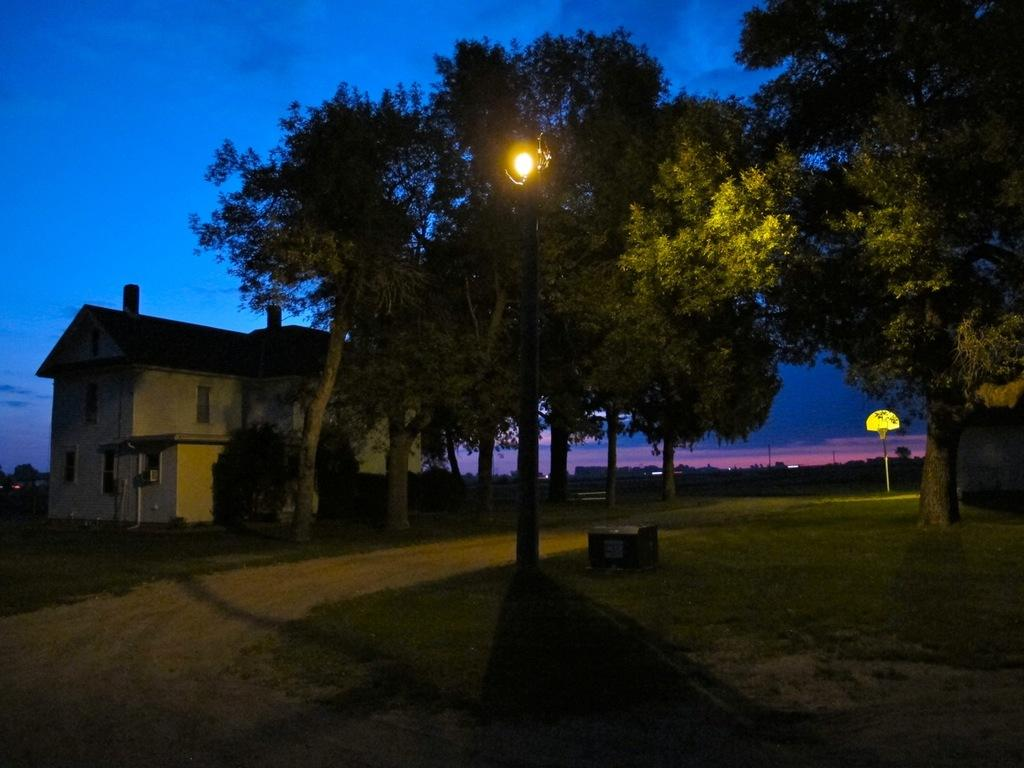What type of vegetation can be seen in the image? There are trees, plants, and grass visible in the image. What structures are present in the image? There are poles and houses in the image. What is the source of illumination in the image? There is light in the image. What can be seen in the background of the image? The sky is visible in the background of the image. How many caves can be seen in the image? There are no caves present in the image. What type of system is being used to control the cannon in the image? There is no cannon present in the image, so there is no system to control it. 